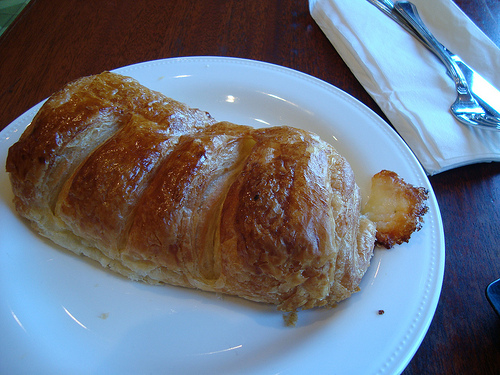<image>
Is the fork on the plate? No. The fork is not positioned on the plate. They may be near each other, but the fork is not supported by or resting on top of the plate. 